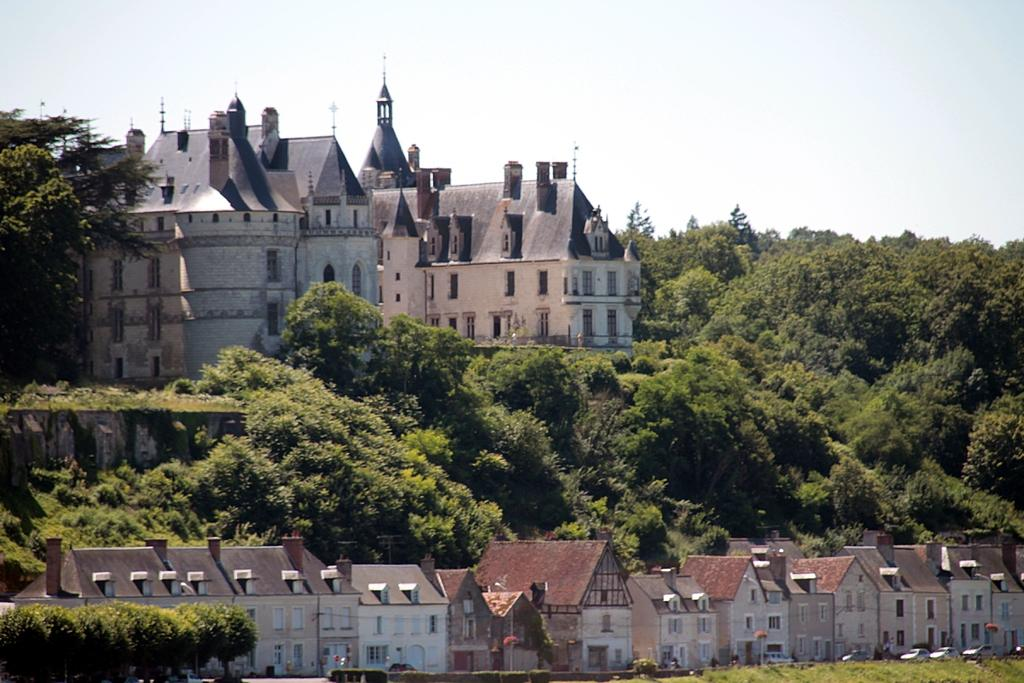What type of structures are present in the image? There are many buildings with windows in the image. What other elements can be seen in the image besides buildings? There are trees in the image. What can be seen in the background of the image? The sky is visible in the background of the image. How many feet are visible on the canvas in the image? There is no canvas or feet present in the image. 